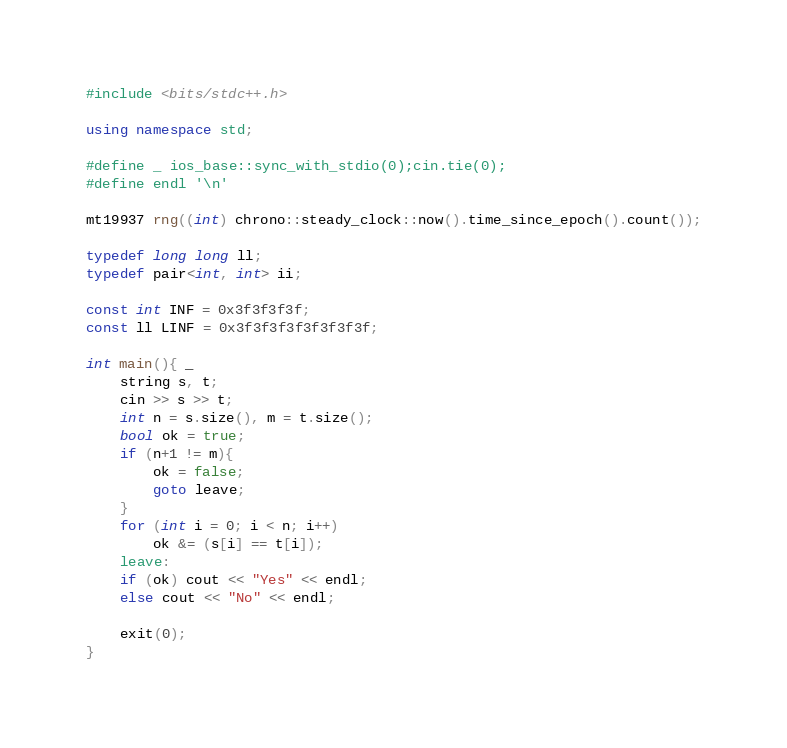<code> <loc_0><loc_0><loc_500><loc_500><_C++_>#include <bits/stdc++.h>

using namespace std;

#define _ ios_base::sync_with_stdio(0);cin.tie(0);
#define endl '\n'

mt19937 rng((int) chrono::steady_clock::now().time_since_epoch().count());

typedef long long ll;
typedef pair<int, int> ii;

const int INF = 0x3f3f3f3f;
const ll LINF = 0x3f3f3f3f3f3f3f3f;

int main(){ _
	string s, t;
	cin >> s >> t;
	int n = s.size(), m = t.size();
	bool ok = true;
	if (n+1 != m){
		ok = false;
		goto leave;
	}
	for (int i = 0; i < n; i++)
		ok &= (s[i] == t[i]);
	leave:	
	if (ok) cout << "Yes" << endl;
	else cout << "No" << endl;
	
	exit(0);
}
</code> 